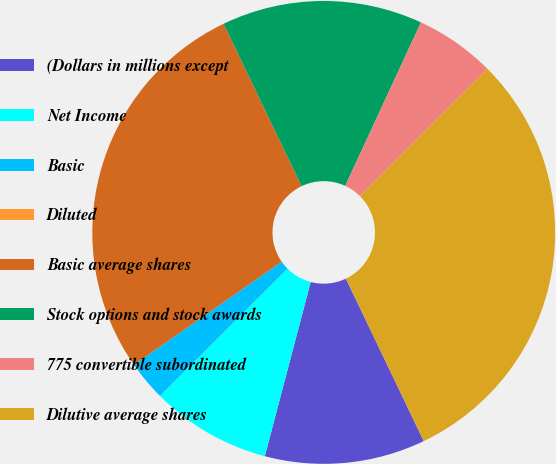<chart> <loc_0><loc_0><loc_500><loc_500><pie_chart><fcel>(Dollars in millions except<fcel>Net Income<fcel>Basic<fcel>Diluted<fcel>Basic average shares<fcel>Stock options and stock awards<fcel>775 convertible subordinated<fcel>Dilutive average shares<nl><fcel>11.21%<fcel>8.41%<fcel>2.8%<fcel>0.0%<fcel>27.57%<fcel>14.02%<fcel>5.61%<fcel>30.38%<nl></chart> 